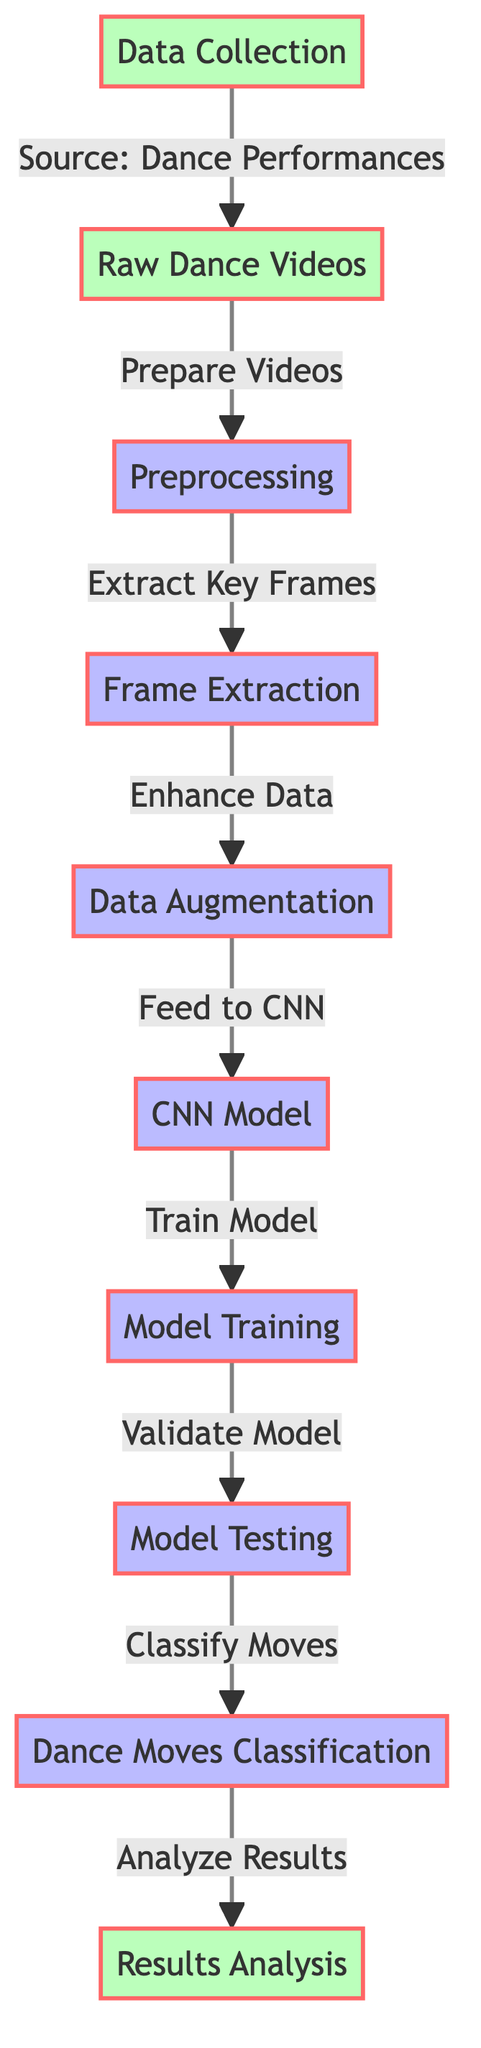What is the initial step in this diagram? The diagram starts with the "Data Collection" node, which is indicated as the first element in the flow. This shows that before any processing, data must first be collected.
Answer: Data Collection How many main processing steps are present in the diagram? The diagram contains five main processing steps: Preprocessing, Frame Extraction, Data Augmentation, Model Training, and Model Testing. Counting these nodes gives the total number of processing steps.
Answer: Five Which node follows the "Raw Dance Videos"? The node "Preprocessing" follows "Raw Dance Videos". This indicates that after collecting raw videos, the next action is to preprocess those videos for further analysis.
Answer: Preprocessing What comes before the "Dance Moves Classification"? The "Model Testing" step comes just before the "Dance Moves Classification", indicating that the model must be tested to ensure it can classify the dance moves accurately.
Answer: Model Testing What is the purpose of the "Data Augmentation" step? The purpose of "Data Augmentation" is to enhance the data by making variations of the existing data, which helps the model learn better by exposing it to more scenarios. This is inferred from the labeling in the diagram.
Answer: Enhance Data What is the final step in the diagram? The final step in the diagram is "Results Analysis". This indicates that after classifying the dance moves, the results will be analyzed for insights and performance evaluation.
Answer: Results Analysis Which node connects the "CNN Model" and "Model Training"? The arrow labeled "Train Model" connects the "CNN Model" to "Model Training", indicating that the output from the CNN model phase flows into the training phase.
Answer: Train Model Which node directly receives input from "Frame Extraction"? The node "Data Augmentation" receives input directly from "Frame Extraction". This shows that after extracting frames from raw videos, the next phase is to augment that data.
Answer: Data Augmentation What is the relationship between "Testing" and "Dance Moves Classification"? "Testing" is directly linked to "Dance Moves Classification" with the label "Classify Moves", showing that the testing phase's results are used to classify the dance moves.
Answer: Classify Moves 